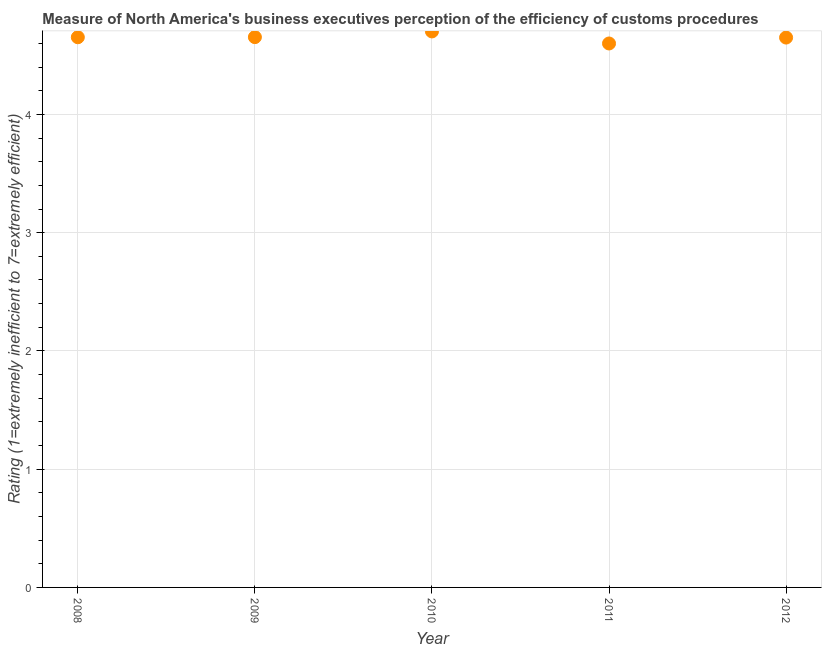What is the rating measuring burden of customs procedure in 2009?
Your answer should be compact. 4.65. Across all years, what is the maximum rating measuring burden of customs procedure?
Your answer should be compact. 4.7. Across all years, what is the minimum rating measuring burden of customs procedure?
Make the answer very short. 4.6. In which year was the rating measuring burden of customs procedure maximum?
Ensure brevity in your answer.  2010. What is the sum of the rating measuring burden of customs procedure?
Ensure brevity in your answer.  23.26. What is the difference between the rating measuring burden of customs procedure in 2009 and 2010?
Make the answer very short. -0.05. What is the average rating measuring burden of customs procedure per year?
Give a very brief answer. 4.65. What is the median rating measuring burden of customs procedure?
Your answer should be very brief. 4.65. In how many years, is the rating measuring burden of customs procedure greater than 0.8 ?
Your answer should be very brief. 5. Do a majority of the years between 2009 and 2008 (inclusive) have rating measuring burden of customs procedure greater than 2.8 ?
Give a very brief answer. No. What is the ratio of the rating measuring burden of customs procedure in 2009 to that in 2010?
Give a very brief answer. 0.99. Is the rating measuring burden of customs procedure in 2011 less than that in 2012?
Keep it short and to the point. Yes. Is the difference between the rating measuring burden of customs procedure in 2008 and 2009 greater than the difference between any two years?
Make the answer very short. No. What is the difference between the highest and the second highest rating measuring burden of customs procedure?
Ensure brevity in your answer.  0.05. What is the difference between the highest and the lowest rating measuring burden of customs procedure?
Ensure brevity in your answer.  0.1. Does the rating measuring burden of customs procedure monotonically increase over the years?
Offer a very short reply. No. What is the difference between two consecutive major ticks on the Y-axis?
Your response must be concise. 1. What is the title of the graph?
Make the answer very short. Measure of North America's business executives perception of the efficiency of customs procedures. What is the label or title of the Y-axis?
Ensure brevity in your answer.  Rating (1=extremely inefficient to 7=extremely efficient). What is the Rating (1=extremely inefficient to 7=extremely efficient) in 2008?
Your answer should be very brief. 4.65. What is the Rating (1=extremely inefficient to 7=extremely efficient) in 2009?
Provide a short and direct response. 4.65. What is the Rating (1=extremely inefficient to 7=extremely efficient) in 2010?
Your answer should be compact. 4.7. What is the Rating (1=extremely inefficient to 7=extremely efficient) in 2012?
Provide a short and direct response. 4.65. What is the difference between the Rating (1=extremely inefficient to 7=extremely efficient) in 2008 and 2009?
Provide a short and direct response. -0. What is the difference between the Rating (1=extremely inefficient to 7=extremely efficient) in 2008 and 2010?
Offer a terse response. -0.05. What is the difference between the Rating (1=extremely inefficient to 7=extremely efficient) in 2008 and 2011?
Your answer should be compact. 0.05. What is the difference between the Rating (1=extremely inefficient to 7=extremely efficient) in 2008 and 2012?
Ensure brevity in your answer.  0. What is the difference between the Rating (1=extremely inefficient to 7=extremely efficient) in 2009 and 2010?
Ensure brevity in your answer.  -0.05. What is the difference between the Rating (1=extremely inefficient to 7=extremely efficient) in 2009 and 2011?
Provide a short and direct response. 0.05. What is the difference between the Rating (1=extremely inefficient to 7=extremely efficient) in 2009 and 2012?
Provide a short and direct response. 0. What is the difference between the Rating (1=extremely inefficient to 7=extremely efficient) in 2010 and 2011?
Make the answer very short. 0.1. What is the difference between the Rating (1=extremely inefficient to 7=extremely efficient) in 2010 and 2012?
Make the answer very short. 0.05. What is the difference between the Rating (1=extremely inefficient to 7=extremely efficient) in 2011 and 2012?
Provide a short and direct response. -0.05. What is the ratio of the Rating (1=extremely inefficient to 7=extremely efficient) in 2008 to that in 2009?
Give a very brief answer. 1. What is the ratio of the Rating (1=extremely inefficient to 7=extremely efficient) in 2008 to that in 2010?
Give a very brief answer. 0.99. What is the ratio of the Rating (1=extremely inefficient to 7=extremely efficient) in 2008 to that in 2012?
Make the answer very short. 1. What is the ratio of the Rating (1=extremely inefficient to 7=extremely efficient) in 2009 to that in 2010?
Make the answer very short. 0.99. What is the ratio of the Rating (1=extremely inefficient to 7=extremely efficient) in 2011 to that in 2012?
Your answer should be compact. 0.99. 